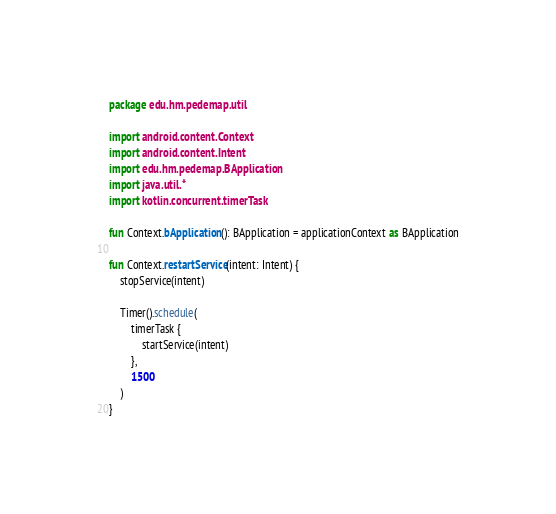<code> <loc_0><loc_0><loc_500><loc_500><_Kotlin_>package edu.hm.pedemap.util

import android.content.Context
import android.content.Intent
import edu.hm.pedemap.BApplication
import java.util.*
import kotlin.concurrent.timerTask

fun Context.bApplication(): BApplication = applicationContext as BApplication

fun Context.restartService(intent: Intent) {
    stopService(intent)

    Timer().schedule(
        timerTask {
            startService(intent)
        },
        1500
    )
}
</code> 